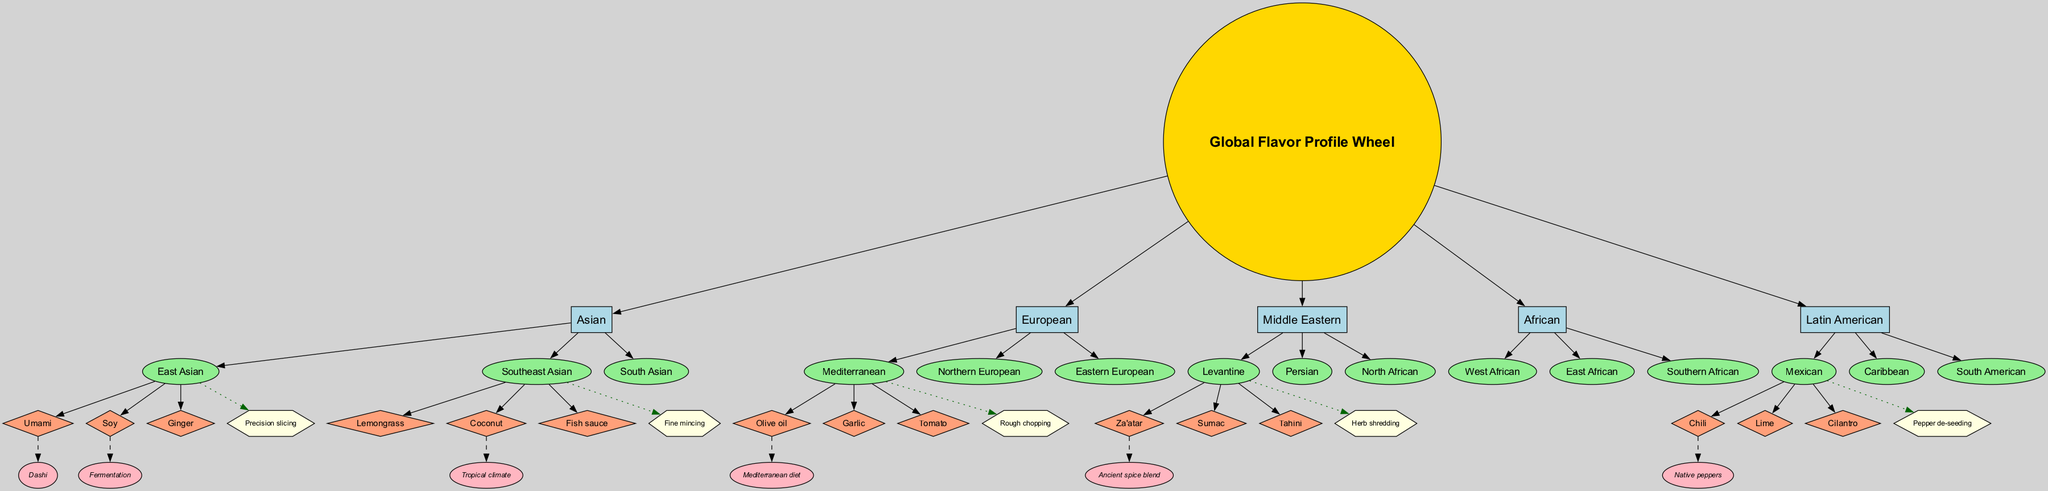What are the main categories in the diagram? The diagram shows five main categories that branch out from the center: Asian, European, Middle Eastern, African, and Latin American. These are the first layer of nodes directly connected to the central "Global Flavor Profile Wheel."
Answer: Asian, European, Middle Eastern, African, Latin American Which subcategory is associated with the Mediterranean cuisine? The Mediterranean is one of the subcategories listed under the European main category in the diagram. It is depicted as an ellipse connected to the European node.
Answer: Mediterranean How many flavor profiles are listed under the East Asian subcategory? The East Asian subcategory has three associated flavor profiles: Umami, Soy, and Ginger. These flavor profiles are represented as diamond-shaped nodes directly linked to the East Asian node.
Answer: 3 What's the influence associated with Olive oil? The diagram shows that Olive oil is influenced by the Mediterranean diet, which is represented as a dashed edge connecting the Olive oil flavor profile to its influence node.
Answer: Mediterranean diet Which knife technique is connected to the Southeast Asian subcategory? The Southeast Asian subcategory is connected to the Fine mincing knife technique, which is shown as a hexagon-shaped node associated with the Southeast Asian node.
Answer: Fine mincing Which flavor profile has a regional influence related to fermentation? The flavor profile Soy, associated with East Asian cuisine, has a regional influence related to fermentation according to the edges depicted in the diagram.
Answer: Soy Which cuisine features the flavor profile Chili? The diagram indicates that the flavor profile Chili is specifically listed under the Mexican subcategory, which is part of the Latin American main category.
Answer: Mexican How many subcategories are listed under African cuisine? The African main category includes three subcategories: West African, East African, and Southern African. Each of these subcategories branches out from the African node, demonstrating a clear relationship.
Answer: 3 Which regional influences are represented in the diagram? The diagram illustrates several regional influences related to specific flavor profiles: Dashi for Umami, Fermentation for Soy, Tropical climate for Coconut, Mediterranean diet for Olive oil, Ancient spice blend for Za'atar, and Native peppers for Chili.
Answer: Dashi, Fermentation, Tropical climate, Mediterranean diet, Ancient spice blend, Native peppers 